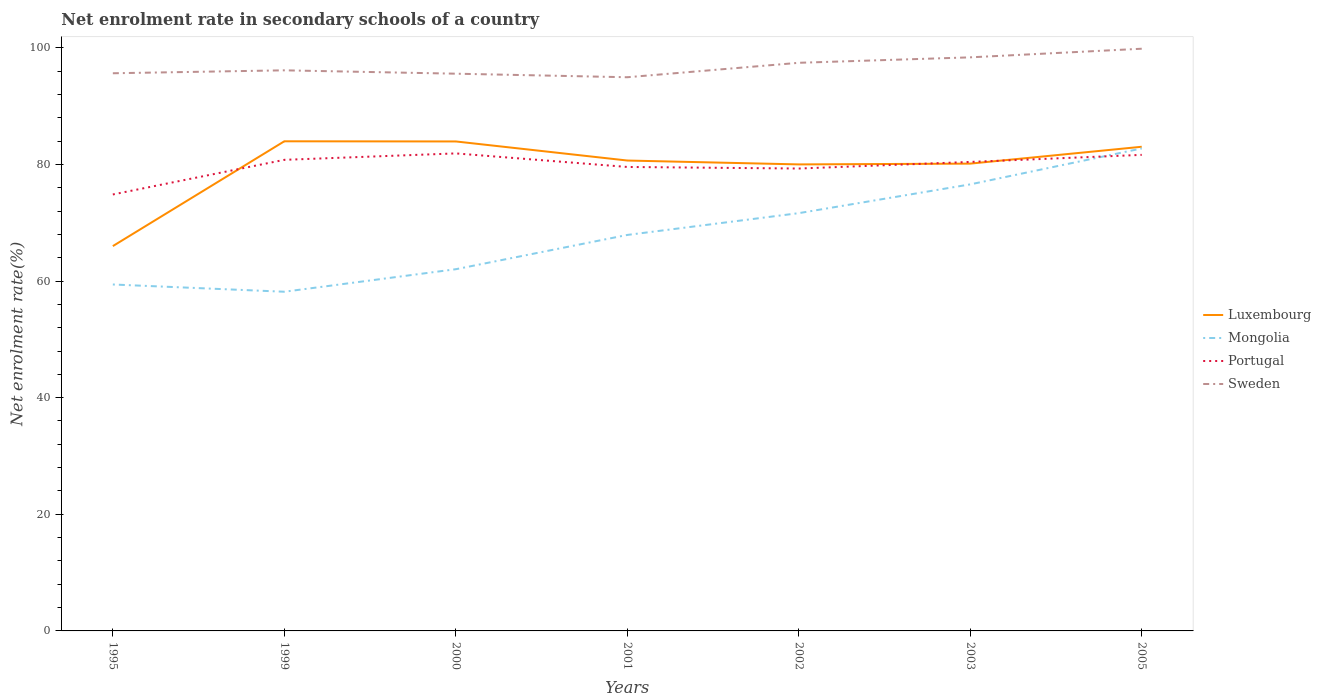Does the line corresponding to Luxembourg intersect with the line corresponding to Sweden?
Give a very brief answer. No. Is the number of lines equal to the number of legend labels?
Provide a short and direct response. Yes. Across all years, what is the maximum net enrolment rate in secondary schools in Portugal?
Offer a terse response. 74.84. What is the total net enrolment rate in secondary schools in Sweden in the graph?
Your answer should be very brief. -2.73. What is the difference between the highest and the second highest net enrolment rate in secondary schools in Mongolia?
Your answer should be compact. 24.58. Is the net enrolment rate in secondary schools in Portugal strictly greater than the net enrolment rate in secondary schools in Mongolia over the years?
Your response must be concise. No. How many lines are there?
Provide a short and direct response. 4. How many years are there in the graph?
Ensure brevity in your answer.  7. Are the values on the major ticks of Y-axis written in scientific E-notation?
Ensure brevity in your answer.  No. Does the graph contain any zero values?
Your response must be concise. No. Where does the legend appear in the graph?
Your response must be concise. Center right. How are the legend labels stacked?
Offer a terse response. Vertical. What is the title of the graph?
Offer a very short reply. Net enrolment rate in secondary schools of a country. What is the label or title of the X-axis?
Offer a very short reply. Years. What is the label or title of the Y-axis?
Ensure brevity in your answer.  Net enrolment rate(%). What is the Net enrolment rate(%) in Luxembourg in 1995?
Your answer should be compact. 65.99. What is the Net enrolment rate(%) of Mongolia in 1995?
Make the answer very short. 59.41. What is the Net enrolment rate(%) of Portugal in 1995?
Keep it short and to the point. 74.84. What is the Net enrolment rate(%) of Sweden in 1995?
Your answer should be compact. 95.63. What is the Net enrolment rate(%) in Luxembourg in 1999?
Provide a succinct answer. 83.96. What is the Net enrolment rate(%) in Mongolia in 1999?
Offer a terse response. 58.16. What is the Net enrolment rate(%) of Portugal in 1999?
Your answer should be very brief. 80.78. What is the Net enrolment rate(%) of Sweden in 1999?
Your answer should be very brief. 96.13. What is the Net enrolment rate(%) in Luxembourg in 2000?
Offer a very short reply. 83.94. What is the Net enrolment rate(%) in Mongolia in 2000?
Your answer should be compact. 62.03. What is the Net enrolment rate(%) of Portugal in 2000?
Make the answer very short. 81.89. What is the Net enrolment rate(%) of Sweden in 2000?
Ensure brevity in your answer.  95.56. What is the Net enrolment rate(%) of Luxembourg in 2001?
Ensure brevity in your answer.  80.66. What is the Net enrolment rate(%) of Mongolia in 2001?
Your answer should be very brief. 67.9. What is the Net enrolment rate(%) of Portugal in 2001?
Provide a succinct answer. 79.56. What is the Net enrolment rate(%) in Sweden in 2001?
Keep it short and to the point. 94.95. What is the Net enrolment rate(%) of Luxembourg in 2002?
Make the answer very short. 80. What is the Net enrolment rate(%) of Mongolia in 2002?
Give a very brief answer. 71.64. What is the Net enrolment rate(%) in Portugal in 2002?
Keep it short and to the point. 79.29. What is the Net enrolment rate(%) in Sweden in 2002?
Your answer should be compact. 97.42. What is the Net enrolment rate(%) in Luxembourg in 2003?
Your answer should be compact. 80.13. What is the Net enrolment rate(%) in Mongolia in 2003?
Your answer should be very brief. 76.58. What is the Net enrolment rate(%) of Portugal in 2003?
Ensure brevity in your answer.  80.42. What is the Net enrolment rate(%) of Sweden in 2003?
Offer a terse response. 98.36. What is the Net enrolment rate(%) in Luxembourg in 2005?
Ensure brevity in your answer.  83.03. What is the Net enrolment rate(%) in Mongolia in 2005?
Offer a terse response. 82.74. What is the Net enrolment rate(%) in Portugal in 2005?
Your answer should be compact. 81.64. What is the Net enrolment rate(%) of Sweden in 2005?
Give a very brief answer. 99.84. Across all years, what is the maximum Net enrolment rate(%) of Luxembourg?
Ensure brevity in your answer.  83.96. Across all years, what is the maximum Net enrolment rate(%) of Mongolia?
Your answer should be compact. 82.74. Across all years, what is the maximum Net enrolment rate(%) in Portugal?
Keep it short and to the point. 81.89. Across all years, what is the maximum Net enrolment rate(%) in Sweden?
Provide a succinct answer. 99.84. Across all years, what is the minimum Net enrolment rate(%) of Luxembourg?
Give a very brief answer. 65.99. Across all years, what is the minimum Net enrolment rate(%) in Mongolia?
Offer a terse response. 58.16. Across all years, what is the minimum Net enrolment rate(%) in Portugal?
Provide a short and direct response. 74.84. Across all years, what is the minimum Net enrolment rate(%) of Sweden?
Offer a terse response. 94.95. What is the total Net enrolment rate(%) in Luxembourg in the graph?
Provide a short and direct response. 557.71. What is the total Net enrolment rate(%) in Mongolia in the graph?
Keep it short and to the point. 478.46. What is the total Net enrolment rate(%) in Portugal in the graph?
Offer a very short reply. 558.43. What is the total Net enrolment rate(%) of Sweden in the graph?
Offer a very short reply. 677.88. What is the difference between the Net enrolment rate(%) in Luxembourg in 1995 and that in 1999?
Offer a terse response. -17.97. What is the difference between the Net enrolment rate(%) in Mongolia in 1995 and that in 1999?
Give a very brief answer. 1.24. What is the difference between the Net enrolment rate(%) of Portugal in 1995 and that in 1999?
Offer a very short reply. -5.94. What is the difference between the Net enrolment rate(%) of Sweden in 1995 and that in 1999?
Your response must be concise. -0.5. What is the difference between the Net enrolment rate(%) of Luxembourg in 1995 and that in 2000?
Offer a terse response. -17.95. What is the difference between the Net enrolment rate(%) in Mongolia in 1995 and that in 2000?
Your answer should be compact. -2.62. What is the difference between the Net enrolment rate(%) in Portugal in 1995 and that in 2000?
Provide a short and direct response. -7.04. What is the difference between the Net enrolment rate(%) of Sweden in 1995 and that in 2000?
Your response must be concise. 0.07. What is the difference between the Net enrolment rate(%) of Luxembourg in 1995 and that in 2001?
Keep it short and to the point. -14.67. What is the difference between the Net enrolment rate(%) of Mongolia in 1995 and that in 2001?
Keep it short and to the point. -8.5. What is the difference between the Net enrolment rate(%) of Portugal in 1995 and that in 2001?
Ensure brevity in your answer.  -4.72. What is the difference between the Net enrolment rate(%) in Sweden in 1995 and that in 2001?
Offer a very short reply. 0.68. What is the difference between the Net enrolment rate(%) in Luxembourg in 1995 and that in 2002?
Provide a succinct answer. -14.01. What is the difference between the Net enrolment rate(%) of Mongolia in 1995 and that in 2002?
Make the answer very short. -12.23. What is the difference between the Net enrolment rate(%) of Portugal in 1995 and that in 2002?
Give a very brief answer. -4.45. What is the difference between the Net enrolment rate(%) of Sweden in 1995 and that in 2002?
Ensure brevity in your answer.  -1.79. What is the difference between the Net enrolment rate(%) in Luxembourg in 1995 and that in 2003?
Ensure brevity in your answer.  -14.14. What is the difference between the Net enrolment rate(%) in Mongolia in 1995 and that in 2003?
Make the answer very short. -17.17. What is the difference between the Net enrolment rate(%) in Portugal in 1995 and that in 2003?
Provide a short and direct response. -5.58. What is the difference between the Net enrolment rate(%) of Sweden in 1995 and that in 2003?
Offer a very short reply. -2.73. What is the difference between the Net enrolment rate(%) in Luxembourg in 1995 and that in 2005?
Offer a terse response. -17.04. What is the difference between the Net enrolment rate(%) of Mongolia in 1995 and that in 2005?
Ensure brevity in your answer.  -23.33. What is the difference between the Net enrolment rate(%) in Portugal in 1995 and that in 2005?
Give a very brief answer. -6.79. What is the difference between the Net enrolment rate(%) in Sweden in 1995 and that in 2005?
Provide a succinct answer. -4.21. What is the difference between the Net enrolment rate(%) of Luxembourg in 1999 and that in 2000?
Provide a succinct answer. 0.03. What is the difference between the Net enrolment rate(%) of Mongolia in 1999 and that in 2000?
Offer a terse response. -3.86. What is the difference between the Net enrolment rate(%) of Portugal in 1999 and that in 2000?
Offer a terse response. -1.1. What is the difference between the Net enrolment rate(%) of Sweden in 1999 and that in 2000?
Give a very brief answer. 0.58. What is the difference between the Net enrolment rate(%) of Luxembourg in 1999 and that in 2001?
Ensure brevity in your answer.  3.3. What is the difference between the Net enrolment rate(%) of Mongolia in 1999 and that in 2001?
Ensure brevity in your answer.  -9.74. What is the difference between the Net enrolment rate(%) in Portugal in 1999 and that in 2001?
Your response must be concise. 1.22. What is the difference between the Net enrolment rate(%) in Sweden in 1999 and that in 2001?
Provide a short and direct response. 1.19. What is the difference between the Net enrolment rate(%) of Luxembourg in 1999 and that in 2002?
Your answer should be very brief. 3.96. What is the difference between the Net enrolment rate(%) of Mongolia in 1999 and that in 2002?
Your answer should be compact. -13.48. What is the difference between the Net enrolment rate(%) in Portugal in 1999 and that in 2002?
Ensure brevity in your answer.  1.49. What is the difference between the Net enrolment rate(%) in Sweden in 1999 and that in 2002?
Your answer should be compact. -1.29. What is the difference between the Net enrolment rate(%) in Luxembourg in 1999 and that in 2003?
Offer a terse response. 3.83. What is the difference between the Net enrolment rate(%) of Mongolia in 1999 and that in 2003?
Provide a short and direct response. -18.41. What is the difference between the Net enrolment rate(%) in Portugal in 1999 and that in 2003?
Offer a terse response. 0.36. What is the difference between the Net enrolment rate(%) of Sweden in 1999 and that in 2003?
Your answer should be very brief. -2.23. What is the difference between the Net enrolment rate(%) of Luxembourg in 1999 and that in 2005?
Your answer should be compact. 0.94. What is the difference between the Net enrolment rate(%) of Mongolia in 1999 and that in 2005?
Your answer should be very brief. -24.58. What is the difference between the Net enrolment rate(%) of Portugal in 1999 and that in 2005?
Provide a succinct answer. -0.85. What is the difference between the Net enrolment rate(%) of Sweden in 1999 and that in 2005?
Offer a terse response. -3.7. What is the difference between the Net enrolment rate(%) of Luxembourg in 2000 and that in 2001?
Your answer should be compact. 3.27. What is the difference between the Net enrolment rate(%) in Mongolia in 2000 and that in 2001?
Offer a terse response. -5.88. What is the difference between the Net enrolment rate(%) of Portugal in 2000 and that in 2001?
Ensure brevity in your answer.  2.33. What is the difference between the Net enrolment rate(%) in Sweden in 2000 and that in 2001?
Offer a very short reply. 0.61. What is the difference between the Net enrolment rate(%) of Luxembourg in 2000 and that in 2002?
Make the answer very short. 3.94. What is the difference between the Net enrolment rate(%) in Mongolia in 2000 and that in 2002?
Keep it short and to the point. -9.61. What is the difference between the Net enrolment rate(%) in Portugal in 2000 and that in 2002?
Ensure brevity in your answer.  2.6. What is the difference between the Net enrolment rate(%) of Sweden in 2000 and that in 2002?
Your response must be concise. -1.87. What is the difference between the Net enrolment rate(%) in Luxembourg in 2000 and that in 2003?
Your answer should be compact. 3.8. What is the difference between the Net enrolment rate(%) in Mongolia in 2000 and that in 2003?
Keep it short and to the point. -14.55. What is the difference between the Net enrolment rate(%) of Portugal in 2000 and that in 2003?
Your answer should be compact. 1.46. What is the difference between the Net enrolment rate(%) in Sweden in 2000 and that in 2003?
Your response must be concise. -2.8. What is the difference between the Net enrolment rate(%) of Luxembourg in 2000 and that in 2005?
Ensure brevity in your answer.  0.91. What is the difference between the Net enrolment rate(%) in Mongolia in 2000 and that in 2005?
Provide a succinct answer. -20.71. What is the difference between the Net enrolment rate(%) of Portugal in 2000 and that in 2005?
Give a very brief answer. 0.25. What is the difference between the Net enrolment rate(%) of Sweden in 2000 and that in 2005?
Your response must be concise. -4.28. What is the difference between the Net enrolment rate(%) of Luxembourg in 2001 and that in 2002?
Offer a very short reply. 0.67. What is the difference between the Net enrolment rate(%) of Mongolia in 2001 and that in 2002?
Your response must be concise. -3.74. What is the difference between the Net enrolment rate(%) in Portugal in 2001 and that in 2002?
Offer a terse response. 0.27. What is the difference between the Net enrolment rate(%) in Sweden in 2001 and that in 2002?
Your answer should be very brief. -2.48. What is the difference between the Net enrolment rate(%) in Luxembourg in 2001 and that in 2003?
Your answer should be compact. 0.53. What is the difference between the Net enrolment rate(%) in Mongolia in 2001 and that in 2003?
Make the answer very short. -8.67. What is the difference between the Net enrolment rate(%) in Portugal in 2001 and that in 2003?
Your answer should be compact. -0.86. What is the difference between the Net enrolment rate(%) of Sweden in 2001 and that in 2003?
Your answer should be very brief. -3.41. What is the difference between the Net enrolment rate(%) in Luxembourg in 2001 and that in 2005?
Your answer should be compact. -2.36. What is the difference between the Net enrolment rate(%) in Mongolia in 2001 and that in 2005?
Offer a very short reply. -14.84. What is the difference between the Net enrolment rate(%) of Portugal in 2001 and that in 2005?
Your answer should be compact. -2.08. What is the difference between the Net enrolment rate(%) of Sweden in 2001 and that in 2005?
Ensure brevity in your answer.  -4.89. What is the difference between the Net enrolment rate(%) in Luxembourg in 2002 and that in 2003?
Offer a very short reply. -0.14. What is the difference between the Net enrolment rate(%) of Mongolia in 2002 and that in 2003?
Make the answer very short. -4.93. What is the difference between the Net enrolment rate(%) of Portugal in 2002 and that in 2003?
Your answer should be very brief. -1.13. What is the difference between the Net enrolment rate(%) in Sweden in 2002 and that in 2003?
Give a very brief answer. -0.94. What is the difference between the Net enrolment rate(%) of Luxembourg in 2002 and that in 2005?
Your answer should be compact. -3.03. What is the difference between the Net enrolment rate(%) of Mongolia in 2002 and that in 2005?
Provide a short and direct response. -11.1. What is the difference between the Net enrolment rate(%) in Portugal in 2002 and that in 2005?
Offer a very short reply. -2.35. What is the difference between the Net enrolment rate(%) in Sweden in 2002 and that in 2005?
Keep it short and to the point. -2.41. What is the difference between the Net enrolment rate(%) of Luxembourg in 2003 and that in 2005?
Offer a very short reply. -2.89. What is the difference between the Net enrolment rate(%) in Mongolia in 2003 and that in 2005?
Provide a succinct answer. -6.17. What is the difference between the Net enrolment rate(%) in Portugal in 2003 and that in 2005?
Your response must be concise. -1.21. What is the difference between the Net enrolment rate(%) of Sweden in 2003 and that in 2005?
Your answer should be very brief. -1.48. What is the difference between the Net enrolment rate(%) in Luxembourg in 1995 and the Net enrolment rate(%) in Mongolia in 1999?
Your answer should be compact. 7.83. What is the difference between the Net enrolment rate(%) of Luxembourg in 1995 and the Net enrolment rate(%) of Portugal in 1999?
Provide a short and direct response. -14.79. What is the difference between the Net enrolment rate(%) of Luxembourg in 1995 and the Net enrolment rate(%) of Sweden in 1999?
Offer a terse response. -30.14. What is the difference between the Net enrolment rate(%) in Mongolia in 1995 and the Net enrolment rate(%) in Portugal in 1999?
Keep it short and to the point. -21.38. What is the difference between the Net enrolment rate(%) in Mongolia in 1995 and the Net enrolment rate(%) in Sweden in 1999?
Your answer should be compact. -36.73. What is the difference between the Net enrolment rate(%) of Portugal in 1995 and the Net enrolment rate(%) of Sweden in 1999?
Offer a terse response. -21.29. What is the difference between the Net enrolment rate(%) in Luxembourg in 1995 and the Net enrolment rate(%) in Mongolia in 2000?
Provide a short and direct response. 3.96. What is the difference between the Net enrolment rate(%) of Luxembourg in 1995 and the Net enrolment rate(%) of Portugal in 2000?
Ensure brevity in your answer.  -15.9. What is the difference between the Net enrolment rate(%) in Luxembourg in 1995 and the Net enrolment rate(%) in Sweden in 2000?
Ensure brevity in your answer.  -29.57. What is the difference between the Net enrolment rate(%) of Mongolia in 1995 and the Net enrolment rate(%) of Portugal in 2000?
Provide a succinct answer. -22.48. What is the difference between the Net enrolment rate(%) in Mongolia in 1995 and the Net enrolment rate(%) in Sweden in 2000?
Make the answer very short. -36.15. What is the difference between the Net enrolment rate(%) in Portugal in 1995 and the Net enrolment rate(%) in Sweden in 2000?
Provide a short and direct response. -20.71. What is the difference between the Net enrolment rate(%) of Luxembourg in 1995 and the Net enrolment rate(%) of Mongolia in 2001?
Offer a terse response. -1.91. What is the difference between the Net enrolment rate(%) of Luxembourg in 1995 and the Net enrolment rate(%) of Portugal in 2001?
Your answer should be very brief. -13.57. What is the difference between the Net enrolment rate(%) of Luxembourg in 1995 and the Net enrolment rate(%) of Sweden in 2001?
Provide a succinct answer. -28.96. What is the difference between the Net enrolment rate(%) in Mongolia in 1995 and the Net enrolment rate(%) in Portugal in 2001?
Your answer should be compact. -20.15. What is the difference between the Net enrolment rate(%) in Mongolia in 1995 and the Net enrolment rate(%) in Sweden in 2001?
Your response must be concise. -35.54. What is the difference between the Net enrolment rate(%) of Portugal in 1995 and the Net enrolment rate(%) of Sweden in 2001?
Provide a succinct answer. -20.1. What is the difference between the Net enrolment rate(%) of Luxembourg in 1995 and the Net enrolment rate(%) of Mongolia in 2002?
Offer a very short reply. -5.65. What is the difference between the Net enrolment rate(%) in Luxembourg in 1995 and the Net enrolment rate(%) in Portugal in 2002?
Ensure brevity in your answer.  -13.3. What is the difference between the Net enrolment rate(%) of Luxembourg in 1995 and the Net enrolment rate(%) of Sweden in 2002?
Make the answer very short. -31.43. What is the difference between the Net enrolment rate(%) of Mongolia in 1995 and the Net enrolment rate(%) of Portugal in 2002?
Your answer should be very brief. -19.88. What is the difference between the Net enrolment rate(%) of Mongolia in 1995 and the Net enrolment rate(%) of Sweden in 2002?
Make the answer very short. -38.02. What is the difference between the Net enrolment rate(%) in Portugal in 1995 and the Net enrolment rate(%) in Sweden in 2002?
Ensure brevity in your answer.  -22.58. What is the difference between the Net enrolment rate(%) of Luxembourg in 1995 and the Net enrolment rate(%) of Mongolia in 2003?
Your answer should be compact. -10.59. What is the difference between the Net enrolment rate(%) of Luxembourg in 1995 and the Net enrolment rate(%) of Portugal in 2003?
Provide a succinct answer. -14.43. What is the difference between the Net enrolment rate(%) of Luxembourg in 1995 and the Net enrolment rate(%) of Sweden in 2003?
Keep it short and to the point. -32.37. What is the difference between the Net enrolment rate(%) in Mongolia in 1995 and the Net enrolment rate(%) in Portugal in 2003?
Your answer should be compact. -21.02. What is the difference between the Net enrolment rate(%) of Mongolia in 1995 and the Net enrolment rate(%) of Sweden in 2003?
Make the answer very short. -38.95. What is the difference between the Net enrolment rate(%) in Portugal in 1995 and the Net enrolment rate(%) in Sweden in 2003?
Offer a very short reply. -23.51. What is the difference between the Net enrolment rate(%) in Luxembourg in 1995 and the Net enrolment rate(%) in Mongolia in 2005?
Provide a short and direct response. -16.75. What is the difference between the Net enrolment rate(%) in Luxembourg in 1995 and the Net enrolment rate(%) in Portugal in 2005?
Ensure brevity in your answer.  -15.65. What is the difference between the Net enrolment rate(%) in Luxembourg in 1995 and the Net enrolment rate(%) in Sweden in 2005?
Provide a short and direct response. -33.85. What is the difference between the Net enrolment rate(%) in Mongolia in 1995 and the Net enrolment rate(%) in Portugal in 2005?
Your answer should be compact. -22.23. What is the difference between the Net enrolment rate(%) in Mongolia in 1995 and the Net enrolment rate(%) in Sweden in 2005?
Make the answer very short. -40.43. What is the difference between the Net enrolment rate(%) of Portugal in 1995 and the Net enrolment rate(%) of Sweden in 2005?
Offer a terse response. -24.99. What is the difference between the Net enrolment rate(%) in Luxembourg in 1999 and the Net enrolment rate(%) in Mongolia in 2000?
Ensure brevity in your answer.  21.94. What is the difference between the Net enrolment rate(%) of Luxembourg in 1999 and the Net enrolment rate(%) of Portugal in 2000?
Offer a terse response. 2.08. What is the difference between the Net enrolment rate(%) of Luxembourg in 1999 and the Net enrolment rate(%) of Sweden in 2000?
Offer a very short reply. -11.59. What is the difference between the Net enrolment rate(%) in Mongolia in 1999 and the Net enrolment rate(%) in Portugal in 2000?
Keep it short and to the point. -23.72. What is the difference between the Net enrolment rate(%) of Mongolia in 1999 and the Net enrolment rate(%) of Sweden in 2000?
Give a very brief answer. -37.39. What is the difference between the Net enrolment rate(%) of Portugal in 1999 and the Net enrolment rate(%) of Sweden in 2000?
Offer a terse response. -14.77. What is the difference between the Net enrolment rate(%) of Luxembourg in 1999 and the Net enrolment rate(%) of Mongolia in 2001?
Offer a terse response. 16.06. What is the difference between the Net enrolment rate(%) in Luxembourg in 1999 and the Net enrolment rate(%) in Portugal in 2001?
Your answer should be compact. 4.4. What is the difference between the Net enrolment rate(%) of Luxembourg in 1999 and the Net enrolment rate(%) of Sweden in 2001?
Keep it short and to the point. -10.98. What is the difference between the Net enrolment rate(%) in Mongolia in 1999 and the Net enrolment rate(%) in Portugal in 2001?
Ensure brevity in your answer.  -21.4. What is the difference between the Net enrolment rate(%) in Mongolia in 1999 and the Net enrolment rate(%) in Sweden in 2001?
Your answer should be very brief. -36.78. What is the difference between the Net enrolment rate(%) of Portugal in 1999 and the Net enrolment rate(%) of Sweden in 2001?
Provide a short and direct response. -14.16. What is the difference between the Net enrolment rate(%) of Luxembourg in 1999 and the Net enrolment rate(%) of Mongolia in 2002?
Your answer should be compact. 12.32. What is the difference between the Net enrolment rate(%) of Luxembourg in 1999 and the Net enrolment rate(%) of Portugal in 2002?
Provide a short and direct response. 4.67. What is the difference between the Net enrolment rate(%) in Luxembourg in 1999 and the Net enrolment rate(%) in Sweden in 2002?
Keep it short and to the point. -13.46. What is the difference between the Net enrolment rate(%) in Mongolia in 1999 and the Net enrolment rate(%) in Portugal in 2002?
Your response must be concise. -21.13. What is the difference between the Net enrolment rate(%) of Mongolia in 1999 and the Net enrolment rate(%) of Sweden in 2002?
Give a very brief answer. -39.26. What is the difference between the Net enrolment rate(%) of Portugal in 1999 and the Net enrolment rate(%) of Sweden in 2002?
Offer a terse response. -16.64. What is the difference between the Net enrolment rate(%) of Luxembourg in 1999 and the Net enrolment rate(%) of Mongolia in 2003?
Ensure brevity in your answer.  7.39. What is the difference between the Net enrolment rate(%) in Luxembourg in 1999 and the Net enrolment rate(%) in Portugal in 2003?
Your answer should be compact. 3.54. What is the difference between the Net enrolment rate(%) in Luxembourg in 1999 and the Net enrolment rate(%) in Sweden in 2003?
Ensure brevity in your answer.  -14.4. What is the difference between the Net enrolment rate(%) of Mongolia in 1999 and the Net enrolment rate(%) of Portugal in 2003?
Your answer should be very brief. -22.26. What is the difference between the Net enrolment rate(%) in Mongolia in 1999 and the Net enrolment rate(%) in Sweden in 2003?
Give a very brief answer. -40.19. What is the difference between the Net enrolment rate(%) in Portugal in 1999 and the Net enrolment rate(%) in Sweden in 2003?
Ensure brevity in your answer.  -17.58. What is the difference between the Net enrolment rate(%) in Luxembourg in 1999 and the Net enrolment rate(%) in Mongolia in 2005?
Your response must be concise. 1.22. What is the difference between the Net enrolment rate(%) in Luxembourg in 1999 and the Net enrolment rate(%) in Portugal in 2005?
Offer a very short reply. 2.33. What is the difference between the Net enrolment rate(%) in Luxembourg in 1999 and the Net enrolment rate(%) in Sweden in 2005?
Ensure brevity in your answer.  -15.87. What is the difference between the Net enrolment rate(%) in Mongolia in 1999 and the Net enrolment rate(%) in Portugal in 2005?
Your answer should be very brief. -23.47. What is the difference between the Net enrolment rate(%) in Mongolia in 1999 and the Net enrolment rate(%) in Sweden in 2005?
Provide a short and direct response. -41.67. What is the difference between the Net enrolment rate(%) in Portugal in 1999 and the Net enrolment rate(%) in Sweden in 2005?
Your answer should be very brief. -19.05. What is the difference between the Net enrolment rate(%) in Luxembourg in 2000 and the Net enrolment rate(%) in Mongolia in 2001?
Offer a very short reply. 16.03. What is the difference between the Net enrolment rate(%) of Luxembourg in 2000 and the Net enrolment rate(%) of Portugal in 2001?
Your response must be concise. 4.37. What is the difference between the Net enrolment rate(%) of Luxembourg in 2000 and the Net enrolment rate(%) of Sweden in 2001?
Provide a short and direct response. -11.01. What is the difference between the Net enrolment rate(%) in Mongolia in 2000 and the Net enrolment rate(%) in Portugal in 2001?
Ensure brevity in your answer.  -17.53. What is the difference between the Net enrolment rate(%) in Mongolia in 2000 and the Net enrolment rate(%) in Sweden in 2001?
Your answer should be very brief. -32.92. What is the difference between the Net enrolment rate(%) of Portugal in 2000 and the Net enrolment rate(%) of Sweden in 2001?
Make the answer very short. -13.06. What is the difference between the Net enrolment rate(%) of Luxembourg in 2000 and the Net enrolment rate(%) of Mongolia in 2002?
Your response must be concise. 12.29. What is the difference between the Net enrolment rate(%) of Luxembourg in 2000 and the Net enrolment rate(%) of Portugal in 2002?
Offer a very short reply. 4.65. What is the difference between the Net enrolment rate(%) in Luxembourg in 2000 and the Net enrolment rate(%) in Sweden in 2002?
Offer a terse response. -13.49. What is the difference between the Net enrolment rate(%) in Mongolia in 2000 and the Net enrolment rate(%) in Portugal in 2002?
Provide a short and direct response. -17.26. What is the difference between the Net enrolment rate(%) in Mongolia in 2000 and the Net enrolment rate(%) in Sweden in 2002?
Offer a very short reply. -35.4. What is the difference between the Net enrolment rate(%) of Portugal in 2000 and the Net enrolment rate(%) of Sweden in 2002?
Offer a very short reply. -15.54. What is the difference between the Net enrolment rate(%) in Luxembourg in 2000 and the Net enrolment rate(%) in Mongolia in 2003?
Give a very brief answer. 7.36. What is the difference between the Net enrolment rate(%) in Luxembourg in 2000 and the Net enrolment rate(%) in Portugal in 2003?
Make the answer very short. 3.51. What is the difference between the Net enrolment rate(%) in Luxembourg in 2000 and the Net enrolment rate(%) in Sweden in 2003?
Your response must be concise. -14.42. What is the difference between the Net enrolment rate(%) of Mongolia in 2000 and the Net enrolment rate(%) of Portugal in 2003?
Offer a terse response. -18.4. What is the difference between the Net enrolment rate(%) in Mongolia in 2000 and the Net enrolment rate(%) in Sweden in 2003?
Your answer should be very brief. -36.33. What is the difference between the Net enrolment rate(%) in Portugal in 2000 and the Net enrolment rate(%) in Sweden in 2003?
Your answer should be compact. -16.47. What is the difference between the Net enrolment rate(%) in Luxembourg in 2000 and the Net enrolment rate(%) in Mongolia in 2005?
Your response must be concise. 1.2. What is the difference between the Net enrolment rate(%) of Luxembourg in 2000 and the Net enrolment rate(%) of Portugal in 2005?
Keep it short and to the point. 2.3. What is the difference between the Net enrolment rate(%) of Luxembourg in 2000 and the Net enrolment rate(%) of Sweden in 2005?
Give a very brief answer. -15.9. What is the difference between the Net enrolment rate(%) of Mongolia in 2000 and the Net enrolment rate(%) of Portugal in 2005?
Make the answer very short. -19.61. What is the difference between the Net enrolment rate(%) of Mongolia in 2000 and the Net enrolment rate(%) of Sweden in 2005?
Keep it short and to the point. -37.81. What is the difference between the Net enrolment rate(%) of Portugal in 2000 and the Net enrolment rate(%) of Sweden in 2005?
Offer a terse response. -17.95. What is the difference between the Net enrolment rate(%) in Luxembourg in 2001 and the Net enrolment rate(%) in Mongolia in 2002?
Provide a short and direct response. 9.02. What is the difference between the Net enrolment rate(%) in Luxembourg in 2001 and the Net enrolment rate(%) in Portugal in 2002?
Provide a succinct answer. 1.37. What is the difference between the Net enrolment rate(%) in Luxembourg in 2001 and the Net enrolment rate(%) in Sweden in 2002?
Give a very brief answer. -16.76. What is the difference between the Net enrolment rate(%) in Mongolia in 2001 and the Net enrolment rate(%) in Portugal in 2002?
Make the answer very short. -11.39. What is the difference between the Net enrolment rate(%) of Mongolia in 2001 and the Net enrolment rate(%) of Sweden in 2002?
Provide a succinct answer. -29.52. What is the difference between the Net enrolment rate(%) in Portugal in 2001 and the Net enrolment rate(%) in Sweden in 2002?
Your response must be concise. -17.86. What is the difference between the Net enrolment rate(%) of Luxembourg in 2001 and the Net enrolment rate(%) of Mongolia in 2003?
Ensure brevity in your answer.  4.09. What is the difference between the Net enrolment rate(%) in Luxembourg in 2001 and the Net enrolment rate(%) in Portugal in 2003?
Ensure brevity in your answer.  0.24. What is the difference between the Net enrolment rate(%) in Luxembourg in 2001 and the Net enrolment rate(%) in Sweden in 2003?
Your answer should be compact. -17.69. What is the difference between the Net enrolment rate(%) of Mongolia in 2001 and the Net enrolment rate(%) of Portugal in 2003?
Your response must be concise. -12.52. What is the difference between the Net enrolment rate(%) in Mongolia in 2001 and the Net enrolment rate(%) in Sweden in 2003?
Give a very brief answer. -30.45. What is the difference between the Net enrolment rate(%) in Portugal in 2001 and the Net enrolment rate(%) in Sweden in 2003?
Your answer should be very brief. -18.8. What is the difference between the Net enrolment rate(%) in Luxembourg in 2001 and the Net enrolment rate(%) in Mongolia in 2005?
Ensure brevity in your answer.  -2.08. What is the difference between the Net enrolment rate(%) in Luxembourg in 2001 and the Net enrolment rate(%) in Portugal in 2005?
Ensure brevity in your answer.  -0.97. What is the difference between the Net enrolment rate(%) in Luxembourg in 2001 and the Net enrolment rate(%) in Sweden in 2005?
Your answer should be compact. -19.17. What is the difference between the Net enrolment rate(%) of Mongolia in 2001 and the Net enrolment rate(%) of Portugal in 2005?
Your answer should be compact. -13.73. What is the difference between the Net enrolment rate(%) in Mongolia in 2001 and the Net enrolment rate(%) in Sweden in 2005?
Your answer should be compact. -31.93. What is the difference between the Net enrolment rate(%) of Portugal in 2001 and the Net enrolment rate(%) of Sweden in 2005?
Your answer should be very brief. -20.28. What is the difference between the Net enrolment rate(%) in Luxembourg in 2002 and the Net enrolment rate(%) in Mongolia in 2003?
Offer a terse response. 3.42. What is the difference between the Net enrolment rate(%) in Luxembourg in 2002 and the Net enrolment rate(%) in Portugal in 2003?
Your answer should be very brief. -0.43. What is the difference between the Net enrolment rate(%) of Luxembourg in 2002 and the Net enrolment rate(%) of Sweden in 2003?
Give a very brief answer. -18.36. What is the difference between the Net enrolment rate(%) in Mongolia in 2002 and the Net enrolment rate(%) in Portugal in 2003?
Your answer should be compact. -8.78. What is the difference between the Net enrolment rate(%) in Mongolia in 2002 and the Net enrolment rate(%) in Sweden in 2003?
Provide a short and direct response. -26.72. What is the difference between the Net enrolment rate(%) of Portugal in 2002 and the Net enrolment rate(%) of Sweden in 2003?
Your response must be concise. -19.07. What is the difference between the Net enrolment rate(%) of Luxembourg in 2002 and the Net enrolment rate(%) of Mongolia in 2005?
Offer a terse response. -2.74. What is the difference between the Net enrolment rate(%) of Luxembourg in 2002 and the Net enrolment rate(%) of Portugal in 2005?
Give a very brief answer. -1.64. What is the difference between the Net enrolment rate(%) of Luxembourg in 2002 and the Net enrolment rate(%) of Sweden in 2005?
Offer a very short reply. -19.84. What is the difference between the Net enrolment rate(%) of Mongolia in 2002 and the Net enrolment rate(%) of Portugal in 2005?
Provide a succinct answer. -10. What is the difference between the Net enrolment rate(%) in Mongolia in 2002 and the Net enrolment rate(%) in Sweden in 2005?
Keep it short and to the point. -28.2. What is the difference between the Net enrolment rate(%) in Portugal in 2002 and the Net enrolment rate(%) in Sweden in 2005?
Make the answer very short. -20.55. What is the difference between the Net enrolment rate(%) in Luxembourg in 2003 and the Net enrolment rate(%) in Mongolia in 2005?
Your response must be concise. -2.61. What is the difference between the Net enrolment rate(%) of Luxembourg in 2003 and the Net enrolment rate(%) of Portugal in 2005?
Your answer should be compact. -1.5. What is the difference between the Net enrolment rate(%) of Luxembourg in 2003 and the Net enrolment rate(%) of Sweden in 2005?
Give a very brief answer. -19.7. What is the difference between the Net enrolment rate(%) in Mongolia in 2003 and the Net enrolment rate(%) in Portugal in 2005?
Your answer should be compact. -5.06. What is the difference between the Net enrolment rate(%) in Mongolia in 2003 and the Net enrolment rate(%) in Sweden in 2005?
Offer a terse response. -23.26. What is the difference between the Net enrolment rate(%) in Portugal in 2003 and the Net enrolment rate(%) in Sweden in 2005?
Ensure brevity in your answer.  -19.41. What is the average Net enrolment rate(%) in Luxembourg per year?
Your response must be concise. 79.67. What is the average Net enrolment rate(%) of Mongolia per year?
Your answer should be compact. 68.35. What is the average Net enrolment rate(%) of Portugal per year?
Provide a short and direct response. 79.78. What is the average Net enrolment rate(%) of Sweden per year?
Provide a succinct answer. 96.84. In the year 1995, what is the difference between the Net enrolment rate(%) in Luxembourg and Net enrolment rate(%) in Mongolia?
Offer a terse response. 6.58. In the year 1995, what is the difference between the Net enrolment rate(%) of Luxembourg and Net enrolment rate(%) of Portugal?
Keep it short and to the point. -8.85. In the year 1995, what is the difference between the Net enrolment rate(%) of Luxembourg and Net enrolment rate(%) of Sweden?
Make the answer very short. -29.64. In the year 1995, what is the difference between the Net enrolment rate(%) in Mongolia and Net enrolment rate(%) in Portugal?
Your answer should be very brief. -15.44. In the year 1995, what is the difference between the Net enrolment rate(%) in Mongolia and Net enrolment rate(%) in Sweden?
Your response must be concise. -36.22. In the year 1995, what is the difference between the Net enrolment rate(%) of Portugal and Net enrolment rate(%) of Sweden?
Provide a succinct answer. -20.79. In the year 1999, what is the difference between the Net enrolment rate(%) in Luxembourg and Net enrolment rate(%) in Mongolia?
Provide a short and direct response. 25.8. In the year 1999, what is the difference between the Net enrolment rate(%) of Luxembourg and Net enrolment rate(%) of Portugal?
Your answer should be very brief. 3.18. In the year 1999, what is the difference between the Net enrolment rate(%) in Luxembourg and Net enrolment rate(%) in Sweden?
Your answer should be very brief. -12.17. In the year 1999, what is the difference between the Net enrolment rate(%) in Mongolia and Net enrolment rate(%) in Portugal?
Make the answer very short. -22.62. In the year 1999, what is the difference between the Net enrolment rate(%) of Mongolia and Net enrolment rate(%) of Sweden?
Your answer should be very brief. -37.97. In the year 1999, what is the difference between the Net enrolment rate(%) of Portugal and Net enrolment rate(%) of Sweden?
Provide a succinct answer. -15.35. In the year 2000, what is the difference between the Net enrolment rate(%) in Luxembourg and Net enrolment rate(%) in Mongolia?
Make the answer very short. 21.91. In the year 2000, what is the difference between the Net enrolment rate(%) of Luxembourg and Net enrolment rate(%) of Portugal?
Ensure brevity in your answer.  2.05. In the year 2000, what is the difference between the Net enrolment rate(%) of Luxembourg and Net enrolment rate(%) of Sweden?
Give a very brief answer. -11.62. In the year 2000, what is the difference between the Net enrolment rate(%) of Mongolia and Net enrolment rate(%) of Portugal?
Give a very brief answer. -19.86. In the year 2000, what is the difference between the Net enrolment rate(%) in Mongolia and Net enrolment rate(%) in Sweden?
Make the answer very short. -33.53. In the year 2000, what is the difference between the Net enrolment rate(%) in Portugal and Net enrolment rate(%) in Sweden?
Ensure brevity in your answer.  -13.67. In the year 2001, what is the difference between the Net enrolment rate(%) in Luxembourg and Net enrolment rate(%) in Mongolia?
Offer a very short reply. 12.76. In the year 2001, what is the difference between the Net enrolment rate(%) of Luxembourg and Net enrolment rate(%) of Portugal?
Provide a short and direct response. 1.1. In the year 2001, what is the difference between the Net enrolment rate(%) in Luxembourg and Net enrolment rate(%) in Sweden?
Offer a terse response. -14.28. In the year 2001, what is the difference between the Net enrolment rate(%) of Mongolia and Net enrolment rate(%) of Portugal?
Offer a very short reply. -11.66. In the year 2001, what is the difference between the Net enrolment rate(%) of Mongolia and Net enrolment rate(%) of Sweden?
Give a very brief answer. -27.04. In the year 2001, what is the difference between the Net enrolment rate(%) of Portugal and Net enrolment rate(%) of Sweden?
Make the answer very short. -15.39. In the year 2002, what is the difference between the Net enrolment rate(%) in Luxembourg and Net enrolment rate(%) in Mongolia?
Give a very brief answer. 8.36. In the year 2002, what is the difference between the Net enrolment rate(%) of Luxembourg and Net enrolment rate(%) of Portugal?
Your response must be concise. 0.71. In the year 2002, what is the difference between the Net enrolment rate(%) of Luxembourg and Net enrolment rate(%) of Sweden?
Your answer should be very brief. -17.42. In the year 2002, what is the difference between the Net enrolment rate(%) in Mongolia and Net enrolment rate(%) in Portugal?
Your response must be concise. -7.65. In the year 2002, what is the difference between the Net enrolment rate(%) of Mongolia and Net enrolment rate(%) of Sweden?
Give a very brief answer. -25.78. In the year 2002, what is the difference between the Net enrolment rate(%) of Portugal and Net enrolment rate(%) of Sweden?
Offer a terse response. -18.13. In the year 2003, what is the difference between the Net enrolment rate(%) in Luxembourg and Net enrolment rate(%) in Mongolia?
Your answer should be compact. 3.56. In the year 2003, what is the difference between the Net enrolment rate(%) in Luxembourg and Net enrolment rate(%) in Portugal?
Keep it short and to the point. -0.29. In the year 2003, what is the difference between the Net enrolment rate(%) of Luxembourg and Net enrolment rate(%) of Sweden?
Your answer should be very brief. -18.22. In the year 2003, what is the difference between the Net enrolment rate(%) of Mongolia and Net enrolment rate(%) of Portugal?
Your response must be concise. -3.85. In the year 2003, what is the difference between the Net enrolment rate(%) of Mongolia and Net enrolment rate(%) of Sweden?
Give a very brief answer. -21.78. In the year 2003, what is the difference between the Net enrolment rate(%) in Portugal and Net enrolment rate(%) in Sweden?
Your answer should be very brief. -17.93. In the year 2005, what is the difference between the Net enrolment rate(%) of Luxembourg and Net enrolment rate(%) of Mongolia?
Make the answer very short. 0.29. In the year 2005, what is the difference between the Net enrolment rate(%) of Luxembourg and Net enrolment rate(%) of Portugal?
Ensure brevity in your answer.  1.39. In the year 2005, what is the difference between the Net enrolment rate(%) of Luxembourg and Net enrolment rate(%) of Sweden?
Offer a very short reply. -16.81. In the year 2005, what is the difference between the Net enrolment rate(%) in Mongolia and Net enrolment rate(%) in Portugal?
Your response must be concise. 1.1. In the year 2005, what is the difference between the Net enrolment rate(%) of Mongolia and Net enrolment rate(%) of Sweden?
Offer a terse response. -17.1. In the year 2005, what is the difference between the Net enrolment rate(%) of Portugal and Net enrolment rate(%) of Sweden?
Keep it short and to the point. -18.2. What is the ratio of the Net enrolment rate(%) of Luxembourg in 1995 to that in 1999?
Provide a succinct answer. 0.79. What is the ratio of the Net enrolment rate(%) of Mongolia in 1995 to that in 1999?
Your response must be concise. 1.02. What is the ratio of the Net enrolment rate(%) of Portugal in 1995 to that in 1999?
Provide a short and direct response. 0.93. What is the ratio of the Net enrolment rate(%) in Luxembourg in 1995 to that in 2000?
Your response must be concise. 0.79. What is the ratio of the Net enrolment rate(%) of Mongolia in 1995 to that in 2000?
Offer a terse response. 0.96. What is the ratio of the Net enrolment rate(%) in Portugal in 1995 to that in 2000?
Offer a terse response. 0.91. What is the ratio of the Net enrolment rate(%) in Luxembourg in 1995 to that in 2001?
Make the answer very short. 0.82. What is the ratio of the Net enrolment rate(%) of Mongolia in 1995 to that in 2001?
Your answer should be compact. 0.87. What is the ratio of the Net enrolment rate(%) in Portugal in 1995 to that in 2001?
Your response must be concise. 0.94. What is the ratio of the Net enrolment rate(%) in Sweden in 1995 to that in 2001?
Your answer should be very brief. 1.01. What is the ratio of the Net enrolment rate(%) in Luxembourg in 1995 to that in 2002?
Your response must be concise. 0.82. What is the ratio of the Net enrolment rate(%) of Mongolia in 1995 to that in 2002?
Make the answer very short. 0.83. What is the ratio of the Net enrolment rate(%) in Portugal in 1995 to that in 2002?
Provide a succinct answer. 0.94. What is the ratio of the Net enrolment rate(%) in Sweden in 1995 to that in 2002?
Your response must be concise. 0.98. What is the ratio of the Net enrolment rate(%) in Luxembourg in 1995 to that in 2003?
Provide a short and direct response. 0.82. What is the ratio of the Net enrolment rate(%) in Mongolia in 1995 to that in 2003?
Give a very brief answer. 0.78. What is the ratio of the Net enrolment rate(%) of Portugal in 1995 to that in 2003?
Offer a terse response. 0.93. What is the ratio of the Net enrolment rate(%) of Sweden in 1995 to that in 2003?
Keep it short and to the point. 0.97. What is the ratio of the Net enrolment rate(%) of Luxembourg in 1995 to that in 2005?
Offer a very short reply. 0.79. What is the ratio of the Net enrolment rate(%) in Mongolia in 1995 to that in 2005?
Keep it short and to the point. 0.72. What is the ratio of the Net enrolment rate(%) in Portugal in 1995 to that in 2005?
Give a very brief answer. 0.92. What is the ratio of the Net enrolment rate(%) in Sweden in 1995 to that in 2005?
Provide a short and direct response. 0.96. What is the ratio of the Net enrolment rate(%) in Luxembourg in 1999 to that in 2000?
Make the answer very short. 1. What is the ratio of the Net enrolment rate(%) of Mongolia in 1999 to that in 2000?
Ensure brevity in your answer.  0.94. What is the ratio of the Net enrolment rate(%) of Portugal in 1999 to that in 2000?
Give a very brief answer. 0.99. What is the ratio of the Net enrolment rate(%) in Luxembourg in 1999 to that in 2001?
Ensure brevity in your answer.  1.04. What is the ratio of the Net enrolment rate(%) in Mongolia in 1999 to that in 2001?
Provide a succinct answer. 0.86. What is the ratio of the Net enrolment rate(%) in Portugal in 1999 to that in 2001?
Provide a succinct answer. 1.02. What is the ratio of the Net enrolment rate(%) in Sweden in 1999 to that in 2001?
Your response must be concise. 1.01. What is the ratio of the Net enrolment rate(%) of Luxembourg in 1999 to that in 2002?
Your answer should be very brief. 1.05. What is the ratio of the Net enrolment rate(%) in Mongolia in 1999 to that in 2002?
Ensure brevity in your answer.  0.81. What is the ratio of the Net enrolment rate(%) of Portugal in 1999 to that in 2002?
Make the answer very short. 1.02. What is the ratio of the Net enrolment rate(%) of Luxembourg in 1999 to that in 2003?
Your response must be concise. 1.05. What is the ratio of the Net enrolment rate(%) in Mongolia in 1999 to that in 2003?
Provide a short and direct response. 0.76. What is the ratio of the Net enrolment rate(%) of Sweden in 1999 to that in 2003?
Offer a very short reply. 0.98. What is the ratio of the Net enrolment rate(%) in Luxembourg in 1999 to that in 2005?
Provide a short and direct response. 1.01. What is the ratio of the Net enrolment rate(%) in Mongolia in 1999 to that in 2005?
Your answer should be very brief. 0.7. What is the ratio of the Net enrolment rate(%) in Sweden in 1999 to that in 2005?
Provide a succinct answer. 0.96. What is the ratio of the Net enrolment rate(%) of Luxembourg in 2000 to that in 2001?
Keep it short and to the point. 1.04. What is the ratio of the Net enrolment rate(%) in Mongolia in 2000 to that in 2001?
Your answer should be very brief. 0.91. What is the ratio of the Net enrolment rate(%) in Portugal in 2000 to that in 2001?
Your answer should be compact. 1.03. What is the ratio of the Net enrolment rate(%) in Sweden in 2000 to that in 2001?
Offer a terse response. 1.01. What is the ratio of the Net enrolment rate(%) of Luxembourg in 2000 to that in 2002?
Make the answer very short. 1.05. What is the ratio of the Net enrolment rate(%) of Mongolia in 2000 to that in 2002?
Your answer should be very brief. 0.87. What is the ratio of the Net enrolment rate(%) in Portugal in 2000 to that in 2002?
Offer a very short reply. 1.03. What is the ratio of the Net enrolment rate(%) in Sweden in 2000 to that in 2002?
Ensure brevity in your answer.  0.98. What is the ratio of the Net enrolment rate(%) of Luxembourg in 2000 to that in 2003?
Ensure brevity in your answer.  1.05. What is the ratio of the Net enrolment rate(%) in Mongolia in 2000 to that in 2003?
Make the answer very short. 0.81. What is the ratio of the Net enrolment rate(%) in Portugal in 2000 to that in 2003?
Make the answer very short. 1.02. What is the ratio of the Net enrolment rate(%) of Sweden in 2000 to that in 2003?
Offer a terse response. 0.97. What is the ratio of the Net enrolment rate(%) of Luxembourg in 2000 to that in 2005?
Give a very brief answer. 1.01. What is the ratio of the Net enrolment rate(%) of Mongolia in 2000 to that in 2005?
Provide a succinct answer. 0.75. What is the ratio of the Net enrolment rate(%) of Sweden in 2000 to that in 2005?
Give a very brief answer. 0.96. What is the ratio of the Net enrolment rate(%) of Luxembourg in 2001 to that in 2002?
Your response must be concise. 1.01. What is the ratio of the Net enrolment rate(%) of Mongolia in 2001 to that in 2002?
Provide a short and direct response. 0.95. What is the ratio of the Net enrolment rate(%) in Portugal in 2001 to that in 2002?
Your response must be concise. 1. What is the ratio of the Net enrolment rate(%) of Sweden in 2001 to that in 2002?
Your answer should be compact. 0.97. What is the ratio of the Net enrolment rate(%) in Luxembourg in 2001 to that in 2003?
Provide a succinct answer. 1.01. What is the ratio of the Net enrolment rate(%) in Mongolia in 2001 to that in 2003?
Give a very brief answer. 0.89. What is the ratio of the Net enrolment rate(%) in Portugal in 2001 to that in 2003?
Make the answer very short. 0.99. What is the ratio of the Net enrolment rate(%) in Sweden in 2001 to that in 2003?
Your answer should be very brief. 0.97. What is the ratio of the Net enrolment rate(%) in Luxembourg in 2001 to that in 2005?
Provide a succinct answer. 0.97. What is the ratio of the Net enrolment rate(%) of Mongolia in 2001 to that in 2005?
Keep it short and to the point. 0.82. What is the ratio of the Net enrolment rate(%) of Portugal in 2001 to that in 2005?
Offer a terse response. 0.97. What is the ratio of the Net enrolment rate(%) of Sweden in 2001 to that in 2005?
Offer a terse response. 0.95. What is the ratio of the Net enrolment rate(%) in Mongolia in 2002 to that in 2003?
Ensure brevity in your answer.  0.94. What is the ratio of the Net enrolment rate(%) of Portugal in 2002 to that in 2003?
Provide a short and direct response. 0.99. What is the ratio of the Net enrolment rate(%) in Sweden in 2002 to that in 2003?
Keep it short and to the point. 0.99. What is the ratio of the Net enrolment rate(%) in Luxembourg in 2002 to that in 2005?
Offer a very short reply. 0.96. What is the ratio of the Net enrolment rate(%) of Mongolia in 2002 to that in 2005?
Ensure brevity in your answer.  0.87. What is the ratio of the Net enrolment rate(%) in Portugal in 2002 to that in 2005?
Your response must be concise. 0.97. What is the ratio of the Net enrolment rate(%) of Sweden in 2002 to that in 2005?
Ensure brevity in your answer.  0.98. What is the ratio of the Net enrolment rate(%) in Luxembourg in 2003 to that in 2005?
Provide a short and direct response. 0.97. What is the ratio of the Net enrolment rate(%) of Mongolia in 2003 to that in 2005?
Provide a succinct answer. 0.93. What is the ratio of the Net enrolment rate(%) in Portugal in 2003 to that in 2005?
Offer a very short reply. 0.99. What is the ratio of the Net enrolment rate(%) of Sweden in 2003 to that in 2005?
Provide a short and direct response. 0.99. What is the difference between the highest and the second highest Net enrolment rate(%) of Luxembourg?
Your response must be concise. 0.03. What is the difference between the highest and the second highest Net enrolment rate(%) of Mongolia?
Your answer should be very brief. 6.17. What is the difference between the highest and the second highest Net enrolment rate(%) in Portugal?
Your answer should be compact. 0.25. What is the difference between the highest and the second highest Net enrolment rate(%) of Sweden?
Make the answer very short. 1.48. What is the difference between the highest and the lowest Net enrolment rate(%) in Luxembourg?
Provide a short and direct response. 17.97. What is the difference between the highest and the lowest Net enrolment rate(%) in Mongolia?
Provide a succinct answer. 24.58. What is the difference between the highest and the lowest Net enrolment rate(%) of Portugal?
Ensure brevity in your answer.  7.04. What is the difference between the highest and the lowest Net enrolment rate(%) of Sweden?
Offer a terse response. 4.89. 